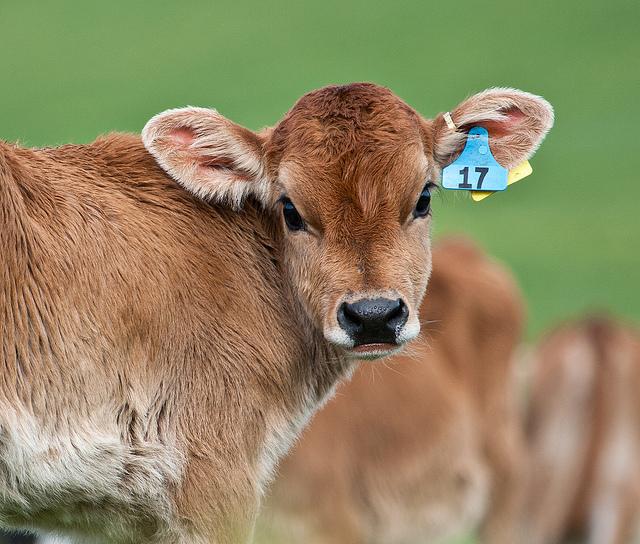What color is the cow?
Keep it brief. Brown. What does the cattle have a tag on its ear?
Give a very brief answer. 17. How many tags does the calf have on it's ear?
Concise answer only. 2. 